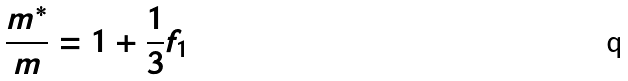Convert formula to latex. <formula><loc_0><loc_0><loc_500><loc_500>\frac { m ^ { * } } { m } = 1 + \frac { 1 } { 3 } f _ { 1 }</formula> 